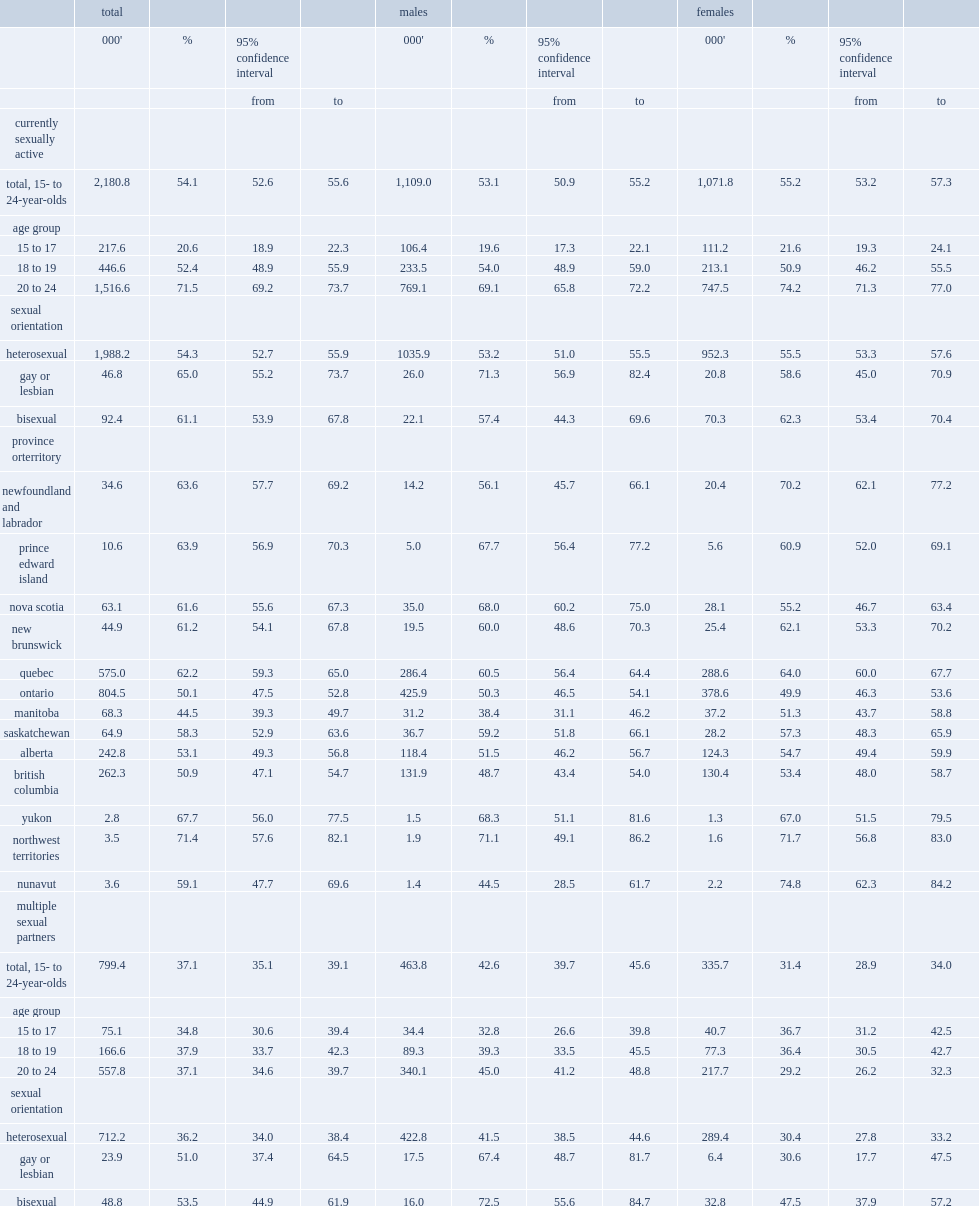What was the percentage of 15- to 24-year-olds in canada reported having had sexual intercourse (vaginal or anal) in the past 12 months? 54.1. How many 15- to 24-year-olds in canada reported having had sexual intercourse (vaginal or anal) in the past 12 months? 2180.8. What was the percentage of people aged 20-24 reported having had sex in the past 12 months? 71.5. What was the percentage of people aged 18-19 reported having had sex in the past 12 months? 52.4. What was the percentage of gay males who were currently sexually active? 71.3. What was the percentage of heterosexual males who were currently sexually active? 53.2. What was the percentage of heterosexual females reported being sexually active? 55.5. What was the percentage of lesbian females reported being sexually active? 58.6. What was the percentage of bisexual females reported being sexually active? 62.3. What was the percentage of youth reported having had intercourse in the previous 12 months in quebec? 62.2. What was the percentage of youth reported having had intercourse in the previous 12 months in yukon? 67.7. What was the percentage of youth reported having had intercourse in the previous 12 months in northwest territories? 71.4. What was the percentage of youth in manitoba had intercourse in the previous 12 months? 44.5. What was the percentage of youth in ontario had intercourse in the previous 12 months? 50.1. What was the percentage of the 15- to 24-year-olds who were currently sexually active reported having had more than one partner in the previous 12 months in 2015/2016? 37.1. Which sex of people was more prevalent to have had multiple sexual partners? Males. What was the proportion of males aged 20 to 24 reported having had multiple sexual partners in the past year? 45.0. What was the proportion of males aged 15 to 17 reported having had multiple sexual partners in the past year? 32.8. What was the proportion of females aged 15 to 17 reported having had multiple sexual partners in the past year? 36.7. What was the proportion of females aged 20 to 24 reported having had multiple sexual partners in the past year? 29.2. What was the percentage of gay males reported having had sex with more than one partner? 67.4. What was the percentage of bisexual males reported having had sex with more than one partner? 72.5. What was the percentage of heterosexual males reported having had sex with more than one partner? 41.5. What was the percentage of heterosexual females reported having had sex with more than one partner? 30.4. What was the percentage of lesbian females reported having had sex with more than one partner? 30.6. What was the percentage of bisexual females had multiple sex partners. 47.5. 